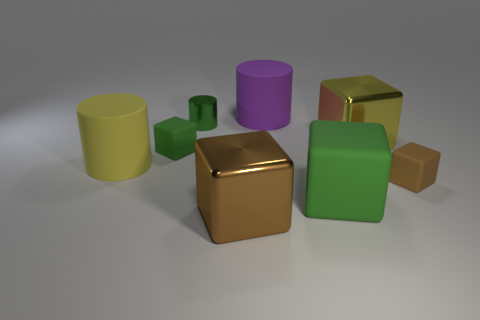Which objects in this image could serve as containers? The yellow and purple cylinders in this image could serve as containers due to their hollow cylindrical shapes. 